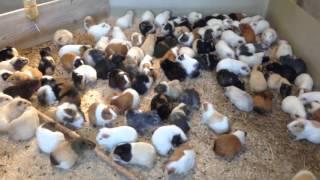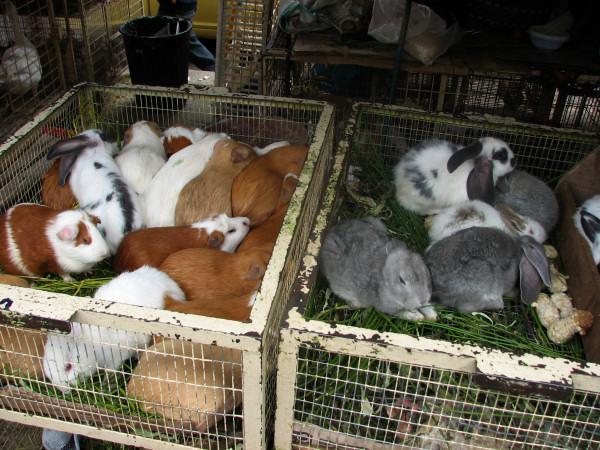The first image is the image on the left, the second image is the image on the right. Given the left and right images, does the statement "Both images show a large number of guinea pigs arranged in rows on stair steps." hold true? Answer yes or no. No. The first image is the image on the left, the second image is the image on the right. Examine the images to the left and right. Is the description "Both images show variously colored hamsters arranged in stepped rows." accurate? Answer yes or no. No. 